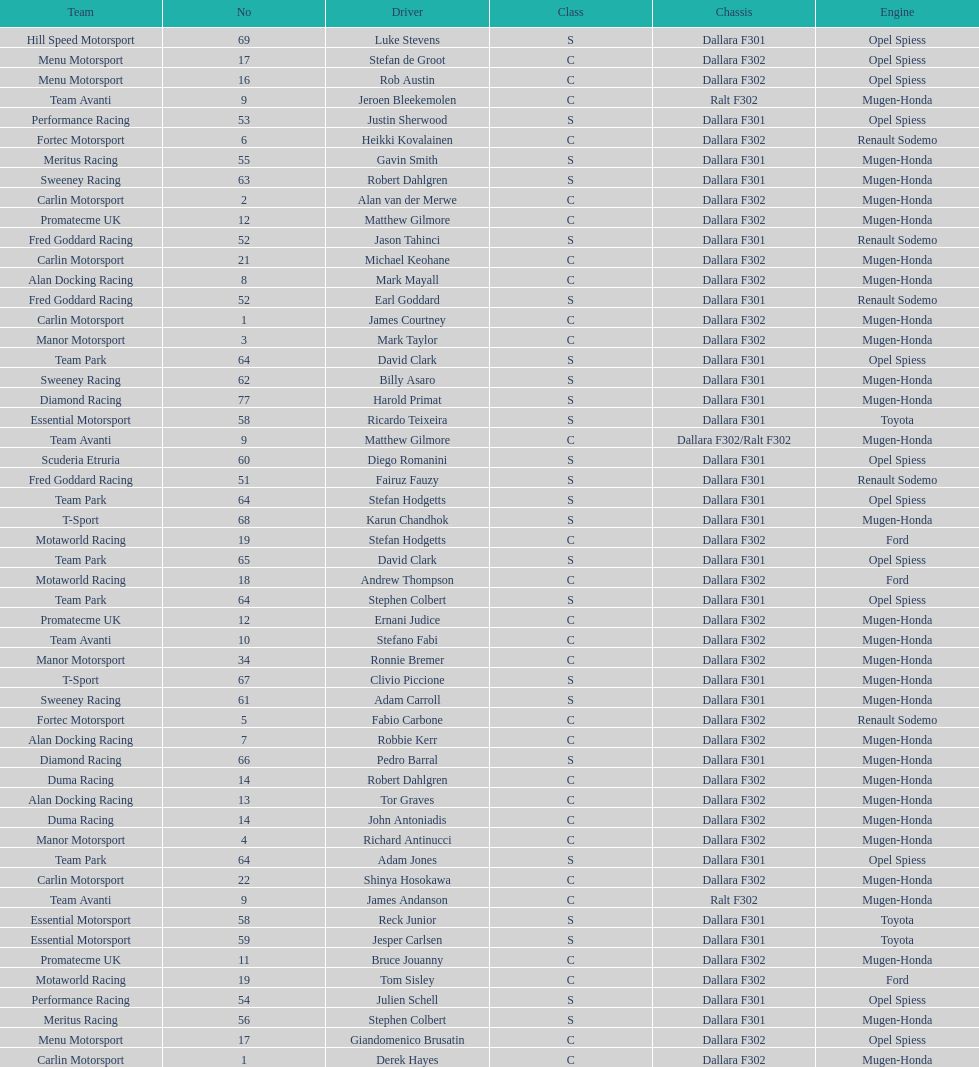How many teams had at least two drivers this season? 17. 